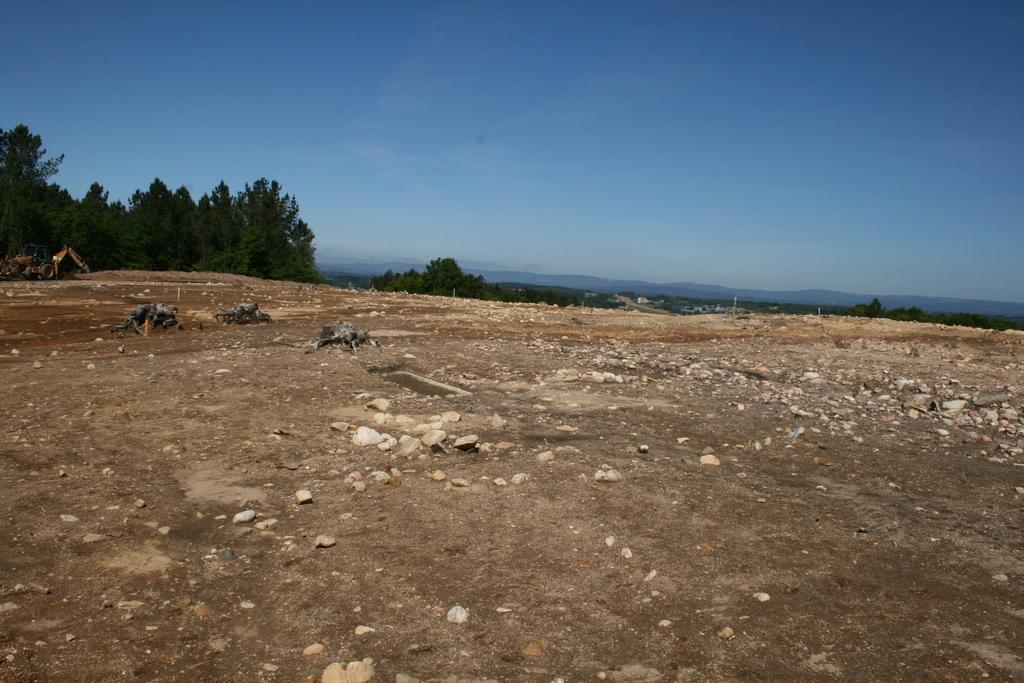How would you summarize this image in a sentence or two? In this picture we can see the ground with some stones. Behind there are some trees and mountains. On the top there is a blue sky. 